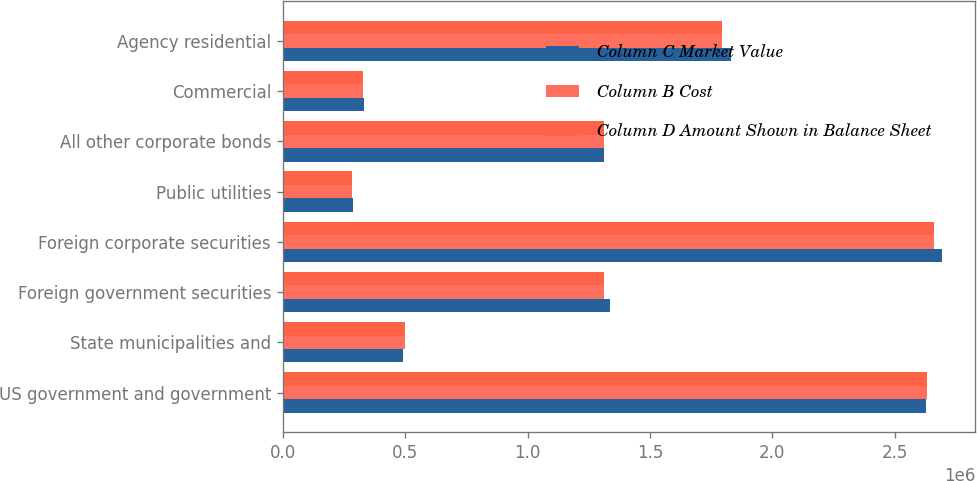Convert chart to OTSL. <chart><loc_0><loc_0><loc_500><loc_500><stacked_bar_chart><ecel><fcel>US government and government<fcel>State municipalities and<fcel>Foreign government securities<fcel>Foreign corporate securities<fcel>Public utilities<fcel>All other corporate bonds<fcel>Commercial<fcel>Agency residential<nl><fcel>Column C Market Value<fcel>2.62945e+06<fcel>490018<fcel>1.33533e+06<fcel>2.69492e+06<fcel>287784<fcel>1.31416e+06<fcel>329883<fcel>1.83276e+06<nl><fcel>Column B Cost<fcel>2.63113e+06<fcel>500094<fcel>1.31416e+06<fcel>2.66106e+06<fcel>283903<fcel>1.31416e+06<fcel>326710<fcel>1.79626e+06<nl><fcel>Column D Amount Shown in Balance Sheet<fcel>2.63113e+06<fcel>500094<fcel>1.31416e+06<fcel>2.66106e+06<fcel>283903<fcel>1.31416e+06<fcel>326710<fcel>1.79626e+06<nl></chart> 